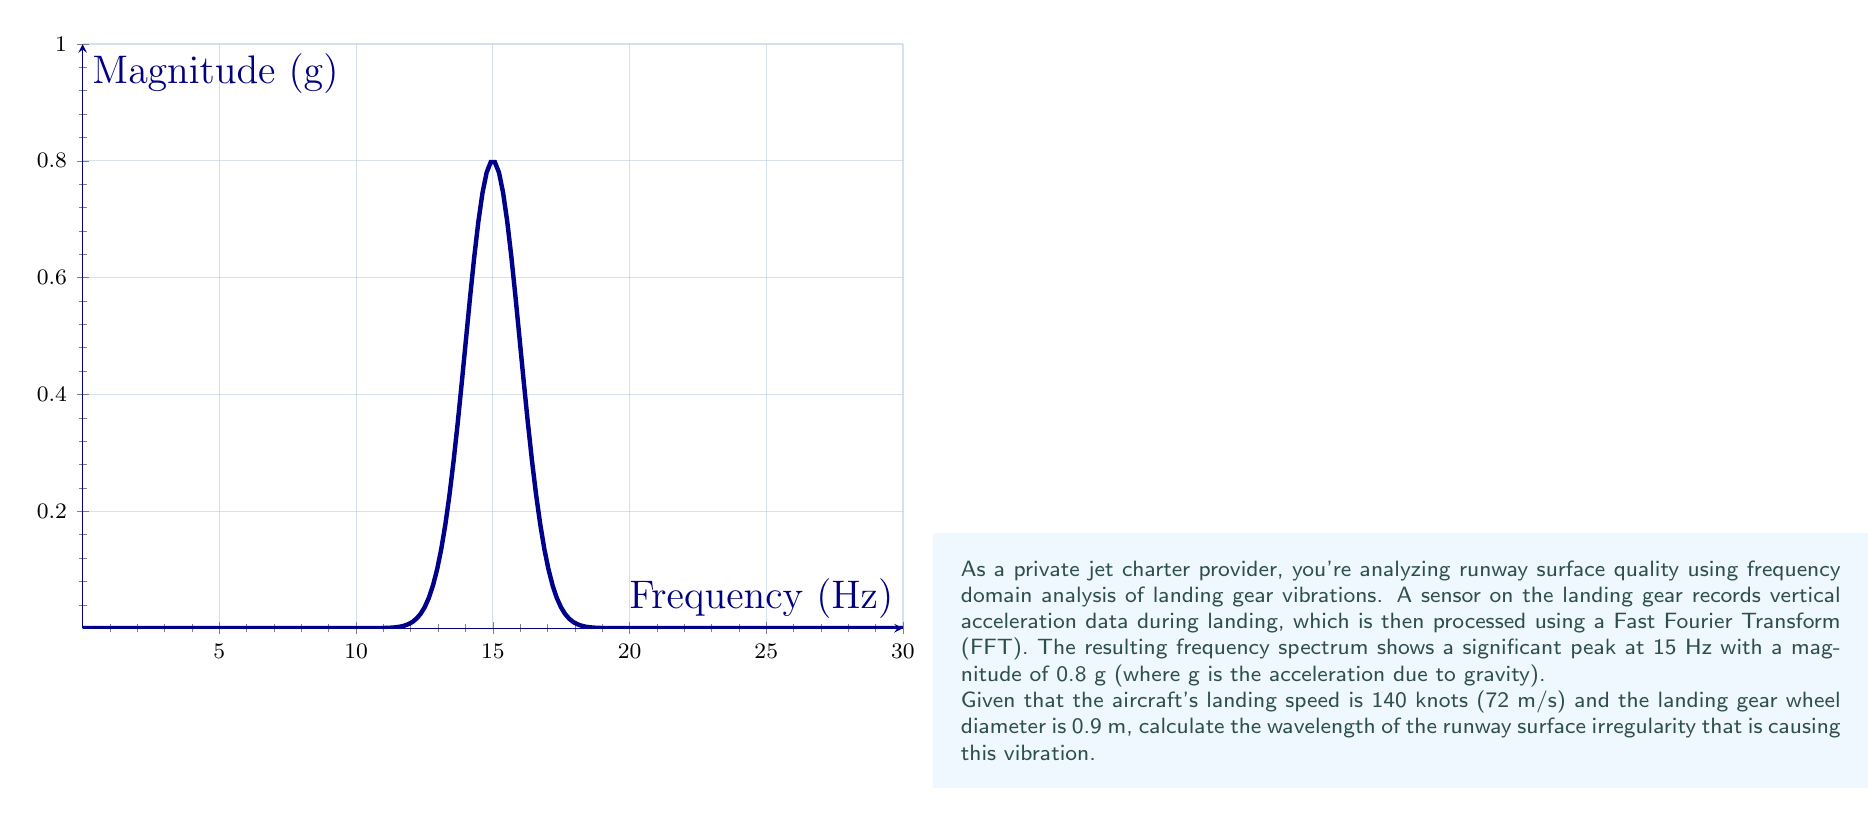Show me your answer to this math problem. Let's approach this step-by-step:

1) First, we need to understand the relationship between frequency, speed, and wavelength. The general equation is:

   $$v = f \lambda$$

   where $v$ is velocity, $f$ is frequency, and $\lambda$ is wavelength.

2) We're given the frequency (15 Hz) and the speed (140 knots or 72 m/s), but we need to consider the rotation of the wheel:

   - Wheel circumference: $C = \pi d = \pi \times 0.9 \text{ m} = 2.83 \text{ m}$
   - Wheel rotational speed: $\frac{72 \text{ m/s}}{2.83 \text{ m/rev}} = 25.44 \text{ rev/s}$

3) The actual frequency of the runway irregularity encountering the wheel is:

   $$f_{\text{actual}} = 15 \text{ Hz} / 25.44 \text{ rev/s} = 0.59 \text{ Hz}$$

4) Now we can use the wavelength equation:

   $$\lambda = \frac{v}{f} = \frac{72 \text{ m/s}}{0.59 \text{ Hz}} = 122.03 \text{ m}$$

5) Therefore, the wavelength of the runway surface irregularity is approximately 122 meters.
Answer: 122 m 